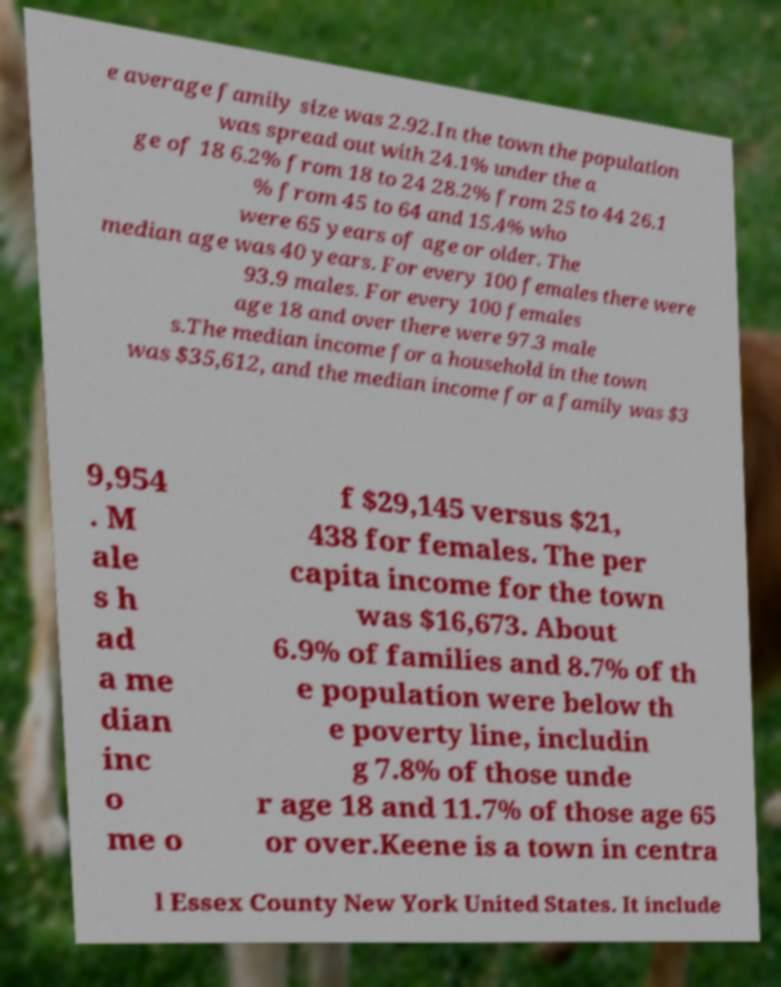Please read and relay the text visible in this image. What does it say? e average family size was 2.92.In the town the population was spread out with 24.1% under the a ge of 18 6.2% from 18 to 24 28.2% from 25 to 44 26.1 % from 45 to 64 and 15.4% who were 65 years of age or older. The median age was 40 years. For every 100 females there were 93.9 males. For every 100 females age 18 and over there were 97.3 male s.The median income for a household in the town was $35,612, and the median income for a family was $3 9,954 . M ale s h ad a me dian inc o me o f $29,145 versus $21, 438 for females. The per capita income for the town was $16,673. About 6.9% of families and 8.7% of th e population were below th e poverty line, includin g 7.8% of those unde r age 18 and 11.7% of those age 65 or over.Keene is a town in centra l Essex County New York United States. It include 